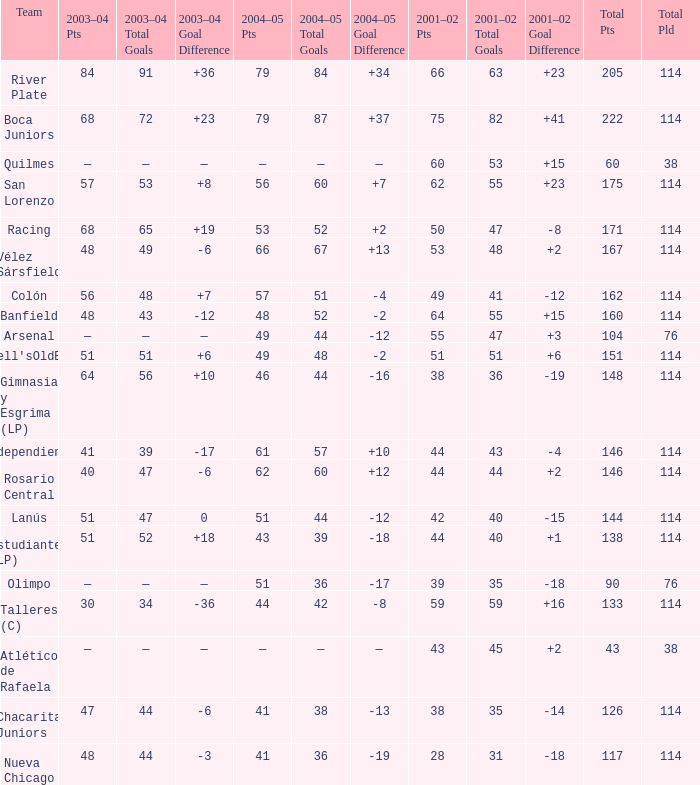Which Team has a Total Pld smaller than 114, and a 2004–05 Pts of 49? Arsenal. 